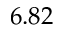Convert formula to latex. <formula><loc_0><loc_0><loc_500><loc_500>6 . 8 2</formula> 